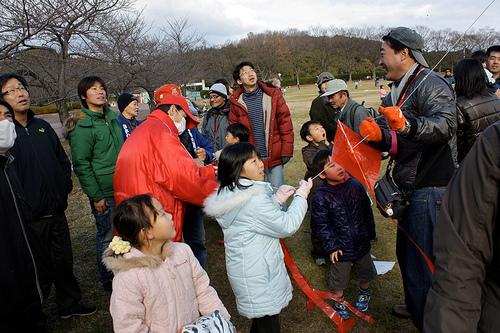What color is the girl holding the kite wearing?
Be succinct. Blue. What does the man in red have over his face?
Be succinct. Mask. What color is the forest?
Quick response, please. Green. 